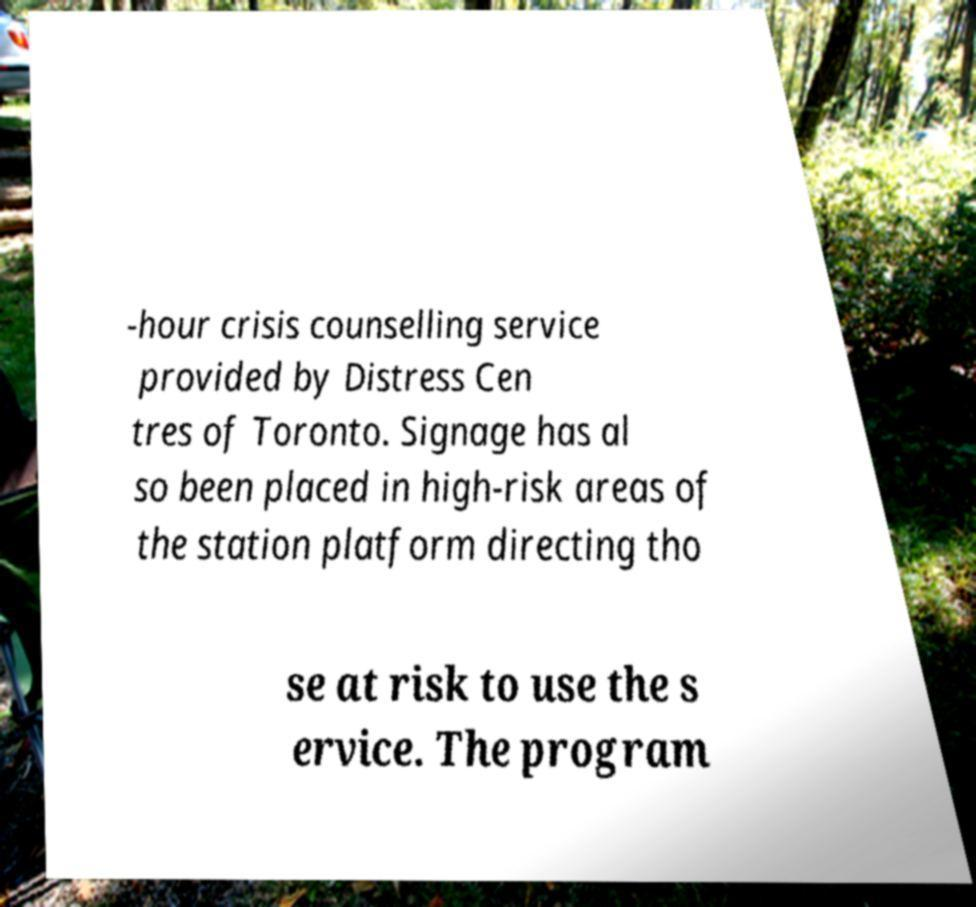For documentation purposes, I need the text within this image transcribed. Could you provide that? -hour crisis counselling service provided by Distress Cen tres of Toronto. Signage has al so been placed in high-risk areas of the station platform directing tho se at risk to use the s ervice. The program 